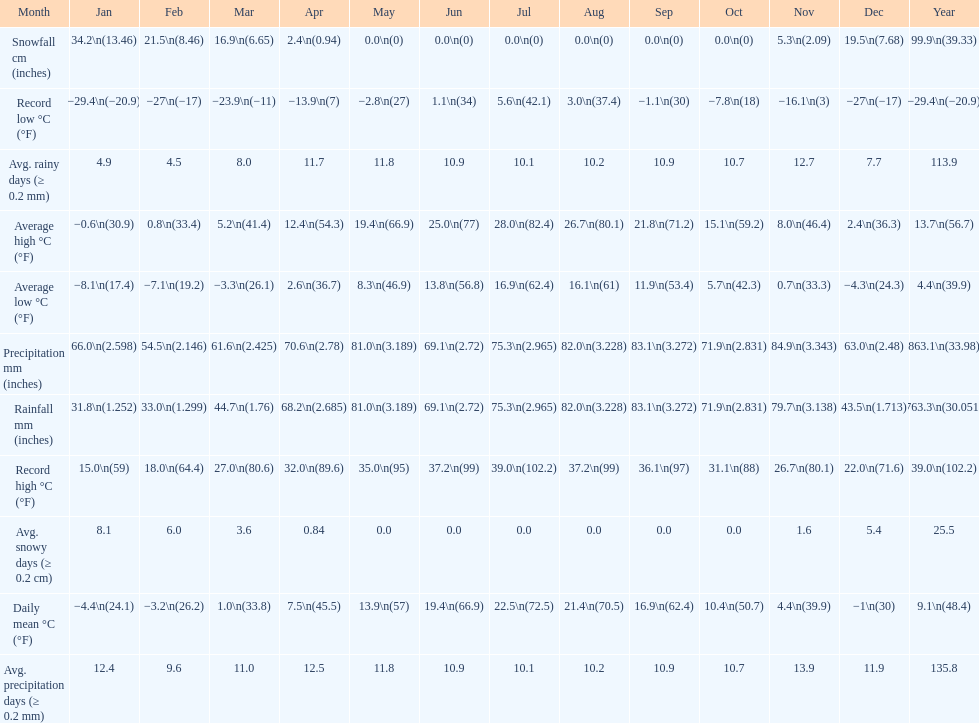Which month had an average high of 21.8 degrees and a record low of -1.1? September. Could you parse the entire table? {'header': ['Month', 'Jan', 'Feb', 'Mar', 'Apr', 'May', 'Jun', 'Jul', 'Aug', 'Sep', 'Oct', 'Nov', 'Dec', 'Year'], 'rows': [['Snowfall cm (inches)', '34.2\\n(13.46)', '21.5\\n(8.46)', '16.9\\n(6.65)', '2.4\\n(0.94)', '0.0\\n(0)', '0.0\\n(0)', '0.0\\n(0)', '0.0\\n(0)', '0.0\\n(0)', '0.0\\n(0)', '5.3\\n(2.09)', '19.5\\n(7.68)', '99.9\\n(39.33)'], ['Record low °C (°F)', '−29.4\\n(−20.9)', '−27\\n(−17)', '−23.9\\n(−11)', '−13.9\\n(7)', '−2.8\\n(27)', '1.1\\n(34)', '5.6\\n(42.1)', '3.0\\n(37.4)', '−1.1\\n(30)', '−7.8\\n(18)', '−16.1\\n(3)', '−27\\n(−17)', '−29.4\\n(−20.9)'], ['Avg. rainy days (≥ 0.2 mm)', '4.9', '4.5', '8.0', '11.7', '11.8', '10.9', '10.1', '10.2', '10.9', '10.7', '12.7', '7.7', '113.9'], ['Average high °C (°F)', '−0.6\\n(30.9)', '0.8\\n(33.4)', '5.2\\n(41.4)', '12.4\\n(54.3)', '19.4\\n(66.9)', '25.0\\n(77)', '28.0\\n(82.4)', '26.7\\n(80.1)', '21.8\\n(71.2)', '15.1\\n(59.2)', '8.0\\n(46.4)', '2.4\\n(36.3)', '13.7\\n(56.7)'], ['Average low °C (°F)', '−8.1\\n(17.4)', '−7.1\\n(19.2)', '−3.3\\n(26.1)', '2.6\\n(36.7)', '8.3\\n(46.9)', '13.8\\n(56.8)', '16.9\\n(62.4)', '16.1\\n(61)', '11.9\\n(53.4)', '5.7\\n(42.3)', '0.7\\n(33.3)', '−4.3\\n(24.3)', '4.4\\n(39.9)'], ['Precipitation mm (inches)', '66.0\\n(2.598)', '54.5\\n(2.146)', '61.6\\n(2.425)', '70.6\\n(2.78)', '81.0\\n(3.189)', '69.1\\n(2.72)', '75.3\\n(2.965)', '82.0\\n(3.228)', '83.1\\n(3.272)', '71.9\\n(2.831)', '84.9\\n(3.343)', '63.0\\n(2.48)', '863.1\\n(33.98)'], ['Rainfall mm (inches)', '31.8\\n(1.252)', '33.0\\n(1.299)', '44.7\\n(1.76)', '68.2\\n(2.685)', '81.0\\n(3.189)', '69.1\\n(2.72)', '75.3\\n(2.965)', '82.0\\n(3.228)', '83.1\\n(3.272)', '71.9\\n(2.831)', '79.7\\n(3.138)', '43.5\\n(1.713)', '763.3\\n(30.051)'], ['Record high °C (°F)', '15.0\\n(59)', '18.0\\n(64.4)', '27.0\\n(80.6)', '32.0\\n(89.6)', '35.0\\n(95)', '37.2\\n(99)', '39.0\\n(102.2)', '37.2\\n(99)', '36.1\\n(97)', '31.1\\n(88)', '26.7\\n(80.1)', '22.0\\n(71.6)', '39.0\\n(102.2)'], ['Avg. snowy days (≥ 0.2 cm)', '8.1', '6.0', '3.6', '0.84', '0.0', '0.0', '0.0', '0.0', '0.0', '0.0', '1.6', '5.4', '25.5'], ['Daily mean °C (°F)', '−4.4\\n(24.1)', '−3.2\\n(26.2)', '1.0\\n(33.8)', '7.5\\n(45.5)', '13.9\\n(57)', '19.4\\n(66.9)', '22.5\\n(72.5)', '21.4\\n(70.5)', '16.9\\n(62.4)', '10.4\\n(50.7)', '4.4\\n(39.9)', '−1\\n(30)', '9.1\\n(48.4)'], ['Avg. precipitation days (≥ 0.2 mm)', '12.4', '9.6', '11.0', '12.5', '11.8', '10.9', '10.1', '10.2', '10.9', '10.7', '13.9', '11.9', '135.8']]} 